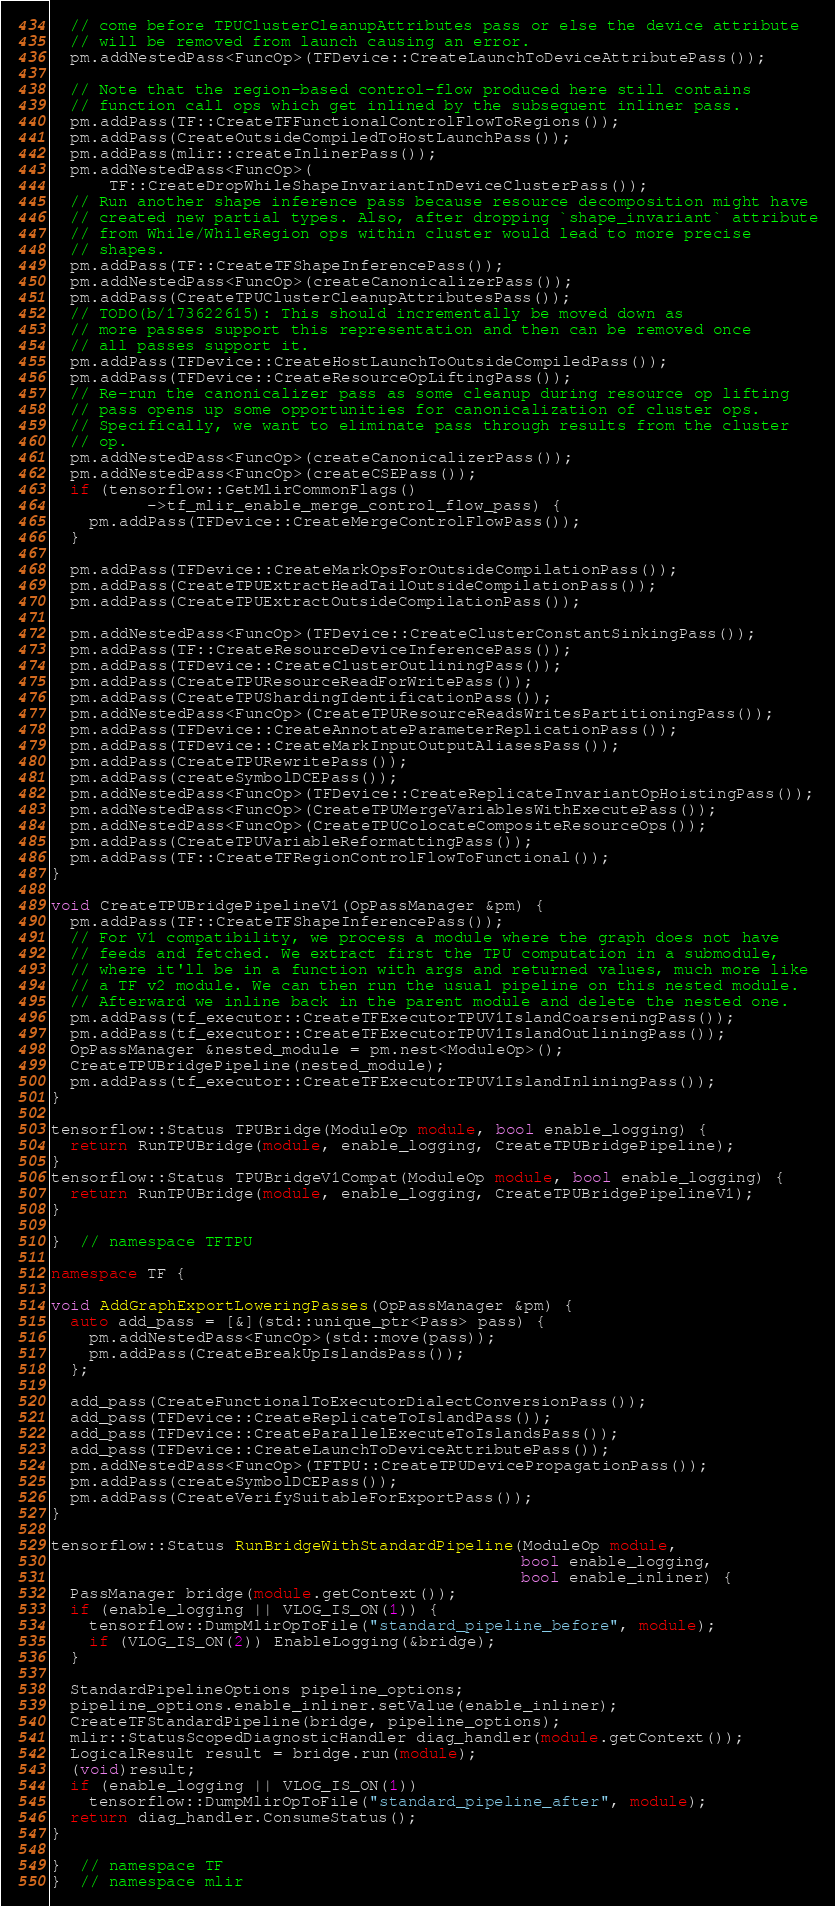<code> <loc_0><loc_0><loc_500><loc_500><_C++_>  // come before TPUClusterCleanupAttributes pass or else the device attribute
  // will be removed from launch causing an error.
  pm.addNestedPass<FuncOp>(TFDevice::CreateLaunchToDeviceAttributePass());

  // Note that the region-based control-flow produced here still contains
  // function call ops which get inlined by the subsequent inliner pass.
  pm.addPass(TF::CreateTFFunctionalControlFlowToRegions());
  pm.addPass(CreateOutsideCompiledToHostLaunchPass());
  pm.addPass(mlir::createInlinerPass());
  pm.addNestedPass<FuncOp>(
      TF::CreateDropWhileShapeInvariantInDeviceClusterPass());
  // Run another shape inference pass because resource decomposition might have
  // created new partial types. Also, after dropping `shape_invariant` attribute
  // from While/WhileRegion ops within cluster would lead to more precise
  // shapes.
  pm.addPass(TF::CreateTFShapeInferencePass());
  pm.addNestedPass<FuncOp>(createCanonicalizerPass());
  pm.addPass(CreateTPUClusterCleanupAttributesPass());
  // TODO(b/173622615): This should incrementally be moved down as
  // more passes support this representation and then can be removed once
  // all passes support it.
  pm.addPass(TFDevice::CreateHostLaunchToOutsideCompiledPass());
  pm.addPass(TFDevice::CreateResourceOpLiftingPass());
  // Re-run the canonicalizer pass as some cleanup during resource op lifting
  // pass opens up some opportunities for canonicalization of cluster ops.
  // Specifically, we want to eliminate pass through results from the cluster
  // op.
  pm.addNestedPass<FuncOp>(createCanonicalizerPass());
  pm.addNestedPass<FuncOp>(createCSEPass());
  if (tensorflow::GetMlirCommonFlags()
          ->tf_mlir_enable_merge_control_flow_pass) {
    pm.addPass(TFDevice::CreateMergeControlFlowPass());
  }

  pm.addPass(TFDevice::CreateMarkOpsForOutsideCompilationPass());
  pm.addPass(CreateTPUExtractHeadTailOutsideCompilationPass());
  pm.addPass(CreateTPUExtractOutsideCompilationPass());

  pm.addNestedPass<FuncOp>(TFDevice::CreateClusterConstantSinkingPass());
  pm.addPass(TF::CreateResourceDeviceInferencePass());
  pm.addPass(TFDevice::CreateClusterOutliningPass());
  pm.addPass(CreateTPUResourceReadForWritePass());
  pm.addPass(CreateTPUShardingIdentificationPass());
  pm.addNestedPass<FuncOp>(CreateTPUResourceReadsWritesPartitioningPass());
  pm.addPass(TFDevice::CreateAnnotateParameterReplicationPass());
  pm.addPass(TFDevice::CreateMarkInputOutputAliasesPass());
  pm.addPass(CreateTPURewritePass());
  pm.addPass(createSymbolDCEPass());
  pm.addNestedPass<FuncOp>(TFDevice::CreateReplicateInvariantOpHoistingPass());
  pm.addNestedPass<FuncOp>(CreateTPUMergeVariablesWithExecutePass());
  pm.addNestedPass<FuncOp>(CreateTPUColocateCompositeResourceOps());
  pm.addPass(CreateTPUVariableReformattingPass());
  pm.addPass(TF::CreateTFRegionControlFlowToFunctional());
}

void CreateTPUBridgePipelineV1(OpPassManager &pm) {
  pm.addPass(TF::CreateTFShapeInferencePass());
  // For V1 compatibility, we process a module where the graph does not have
  // feeds and fetched. We extract first the TPU computation in a submodule,
  // where it'll be in a function with args and returned values, much more like
  // a TF v2 module. We can then run the usual pipeline on this nested module.
  // Afterward we inline back in the parent module and delete the nested one.
  pm.addPass(tf_executor::CreateTFExecutorTPUV1IslandCoarseningPass());
  pm.addPass(tf_executor::CreateTFExecutorTPUV1IslandOutliningPass());
  OpPassManager &nested_module = pm.nest<ModuleOp>();
  CreateTPUBridgePipeline(nested_module);
  pm.addPass(tf_executor::CreateTFExecutorTPUV1IslandInliningPass());
}

tensorflow::Status TPUBridge(ModuleOp module, bool enable_logging) {
  return RunTPUBridge(module, enable_logging, CreateTPUBridgePipeline);
}
tensorflow::Status TPUBridgeV1Compat(ModuleOp module, bool enable_logging) {
  return RunTPUBridge(module, enable_logging, CreateTPUBridgePipelineV1);
}

}  // namespace TFTPU

namespace TF {

void AddGraphExportLoweringPasses(OpPassManager &pm) {
  auto add_pass = [&](std::unique_ptr<Pass> pass) {
    pm.addNestedPass<FuncOp>(std::move(pass));
    pm.addPass(CreateBreakUpIslandsPass());
  };

  add_pass(CreateFunctionalToExecutorDialectConversionPass());
  add_pass(TFDevice::CreateReplicateToIslandPass());
  add_pass(TFDevice::CreateParallelExecuteToIslandsPass());
  add_pass(TFDevice::CreateLaunchToDeviceAttributePass());
  pm.addNestedPass<FuncOp>(TFTPU::CreateTPUDevicePropagationPass());
  pm.addPass(createSymbolDCEPass());
  pm.addPass(CreateVerifySuitableForExportPass());
}

tensorflow::Status RunBridgeWithStandardPipeline(ModuleOp module,
                                                 bool enable_logging,
                                                 bool enable_inliner) {
  PassManager bridge(module.getContext());
  if (enable_logging || VLOG_IS_ON(1)) {
    tensorflow::DumpMlirOpToFile("standard_pipeline_before", module);
    if (VLOG_IS_ON(2)) EnableLogging(&bridge);
  }

  StandardPipelineOptions pipeline_options;
  pipeline_options.enable_inliner.setValue(enable_inliner);
  CreateTFStandardPipeline(bridge, pipeline_options);
  mlir::StatusScopedDiagnosticHandler diag_handler(module.getContext());
  LogicalResult result = bridge.run(module);
  (void)result;
  if (enable_logging || VLOG_IS_ON(1))
    tensorflow::DumpMlirOpToFile("standard_pipeline_after", module);
  return diag_handler.ConsumeStatus();
}

}  // namespace TF
}  // namespace mlir
</code> 